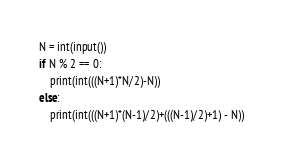<code> <loc_0><loc_0><loc_500><loc_500><_Python_>N = int(input())
if N % 2 == 0:
    print(int(((N+1)*N/2)-N))
else:
    print(int(((N+1)*(N-1)/2)+(((N-1)/2)+1) - N))








</code> 